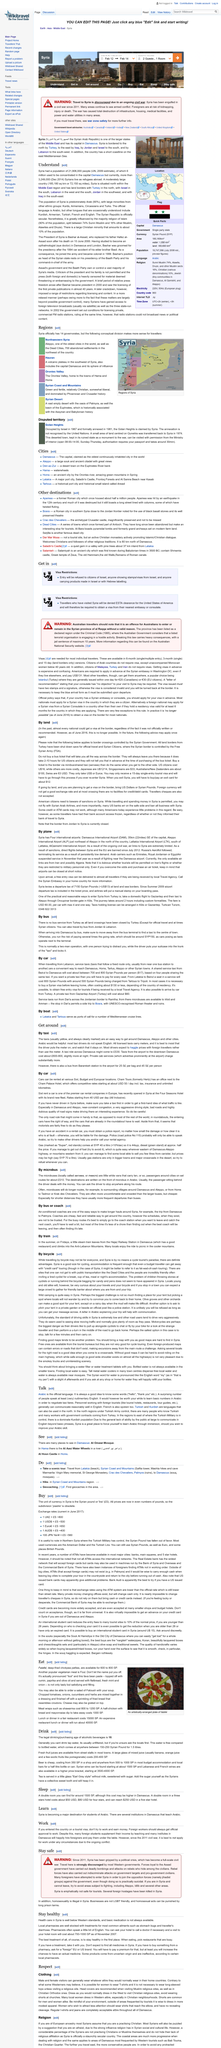Indicate a few pertinent items in this graphic. The main topic of the article is a Middle Eastern country called Syria. According to recent estimates, the population of Syria is predominantly Arab, with approximately 90% of the population identifying as such. Syria is bordered by Turkey to the north. 